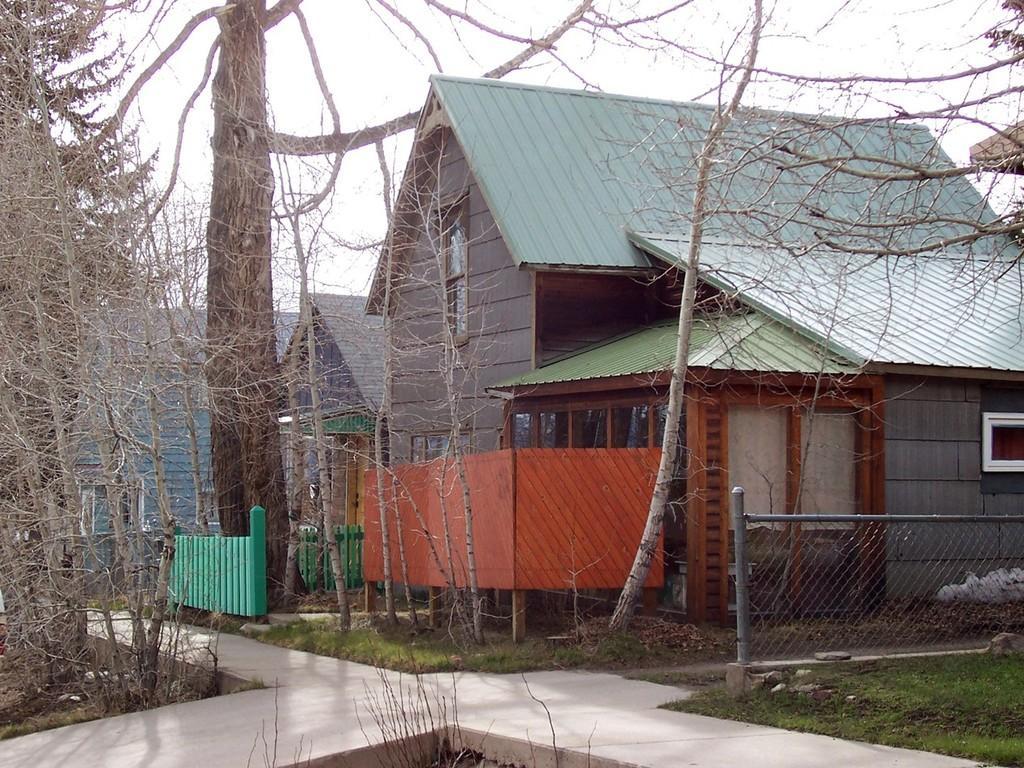Can you describe this image briefly? In this image, we can see few houses with glass windows. Mesh, poles, grass, walkway, trees, fencing we can see. Top of the image, there is a sky. 